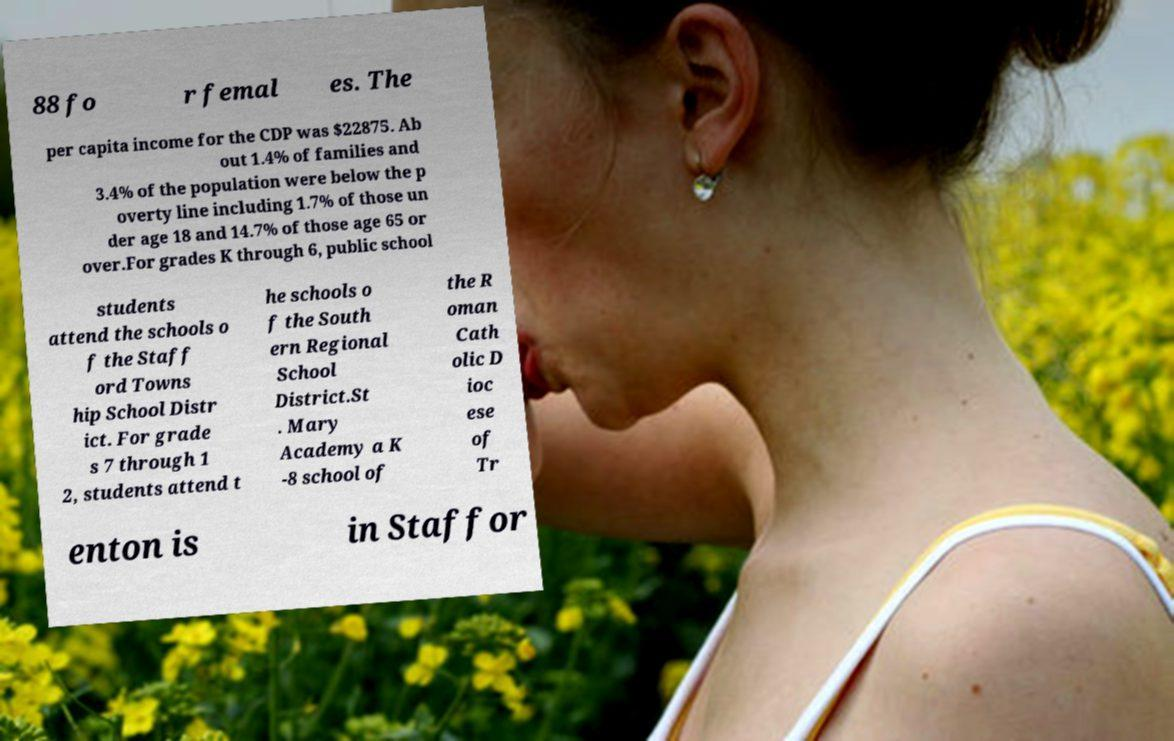What messages or text are displayed in this image? I need them in a readable, typed format. 88 fo r femal es. The per capita income for the CDP was $22875. Ab out 1.4% of families and 3.4% of the population were below the p overty line including 1.7% of those un der age 18 and 14.7% of those age 65 or over.For grades K through 6, public school students attend the schools o f the Staff ord Towns hip School Distr ict. For grade s 7 through 1 2, students attend t he schools o f the South ern Regional School District.St . Mary Academy a K -8 school of the R oman Cath olic D ioc ese of Tr enton is in Staffor 